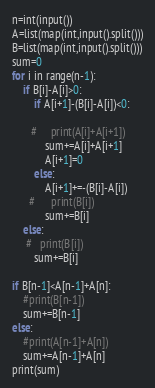<code> <loc_0><loc_0><loc_500><loc_500><_Python_>n=int(input())
A=list(map(int,input().split()))
B=list(map(int,input().split()))
sum=0
for i in range(n-1):
    if B[i]-A[i]>0:
        if A[i+1]-(B[i]-A[i])<0:
            
       #     print(A[i]+A[i+1])
            sum+=A[i]+A[i+1]
            A[i+1]=0
        else:
            A[i+1]+=-(B[i]-A[i])
      #      print(B[i])
            sum+=B[i]
    else:
     #   print(B[i])
        sum+=B[i]

if B[n-1]<A[n-1]+A[n]:
    #print(B[n-1])
    sum+=B[n-1]
else:
    #print(A[n-1]+A[n])
    sum+=A[n-1]+A[n]
print(sum)
</code> 